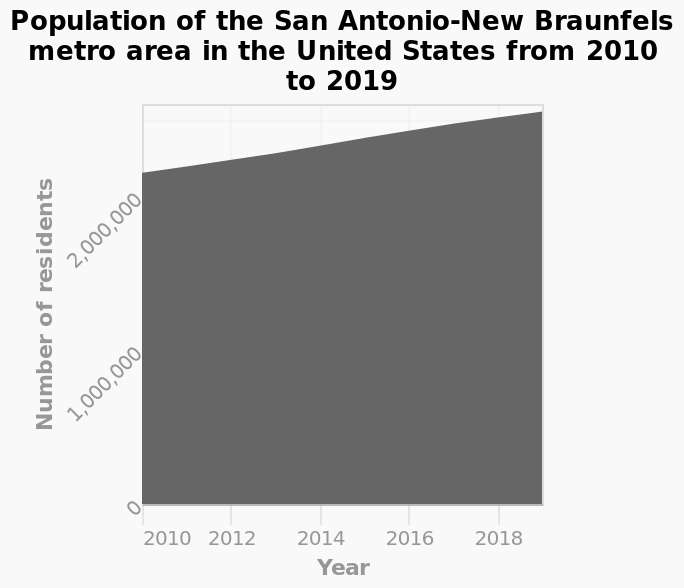<image>
Has the population of the San Antonio-New Braunfels metro area in the United States increased or decreased between 2010 and 2019?  The population of the San Antonio-New Braunfels metro area in the United States has increased between the years 2010 and 2019. In which country is the San Antonio-New Braunfels metro area located?  The San Antonio-New Braunfels metro area is located in the United States. Offer a thorough analysis of the image. The population of the San Antonio-New Braunfels metro area in the United States has increased. between the years 2010 and 2019. The number of residents in the San Antonio-New Braunfels metro area in the United States has increased between the years 2010 and 2019. Furthermore, the number of residents in the San Antonio-New Braunfels metro area in the United States has increased each/every year from 2010 to 2019. The total increase in the number of residents between the years 2010 and 2019 is less than 1,000,000, the total increase appears closer to 500,000 - this is an approximation. What is plotted along the x-axis of the area graph?  Along the x-axis of the area graph, the years from 2010 to 2019 are plotted. What information is plotted on the y-axis of the area graph?  The y-axis of the area graph is labeled "Number of residents" and is drawn on a linear scale from 0 to 2,500,000. 